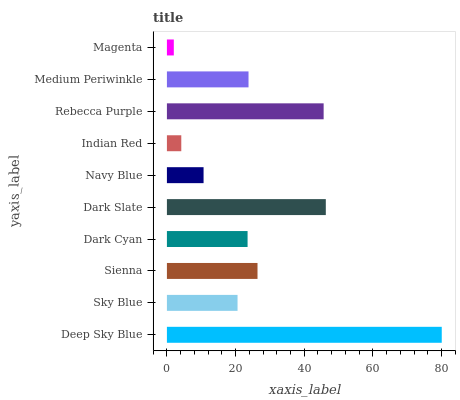Is Magenta the minimum?
Answer yes or no. Yes. Is Deep Sky Blue the maximum?
Answer yes or no. Yes. Is Sky Blue the minimum?
Answer yes or no. No. Is Sky Blue the maximum?
Answer yes or no. No. Is Deep Sky Blue greater than Sky Blue?
Answer yes or no. Yes. Is Sky Blue less than Deep Sky Blue?
Answer yes or no. Yes. Is Sky Blue greater than Deep Sky Blue?
Answer yes or no. No. Is Deep Sky Blue less than Sky Blue?
Answer yes or no. No. Is Medium Periwinkle the high median?
Answer yes or no. Yes. Is Dark Cyan the low median?
Answer yes or no. Yes. Is Sienna the high median?
Answer yes or no. No. Is Sienna the low median?
Answer yes or no. No. 